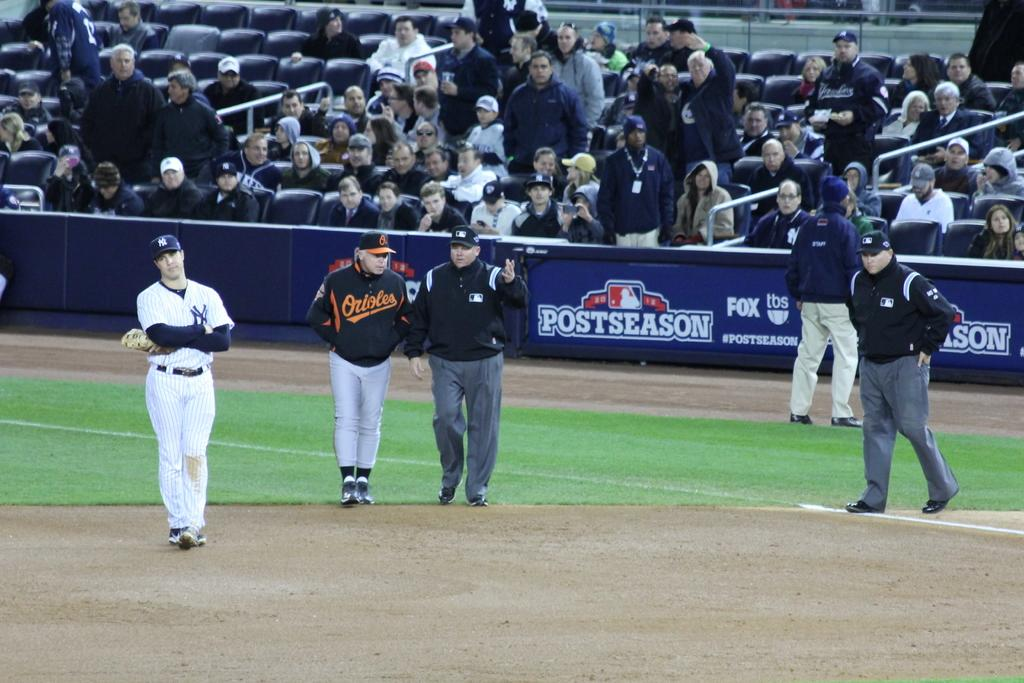Provide a one-sentence caption for the provided image. ny yankees and orioles playing a postseason mlb game. 